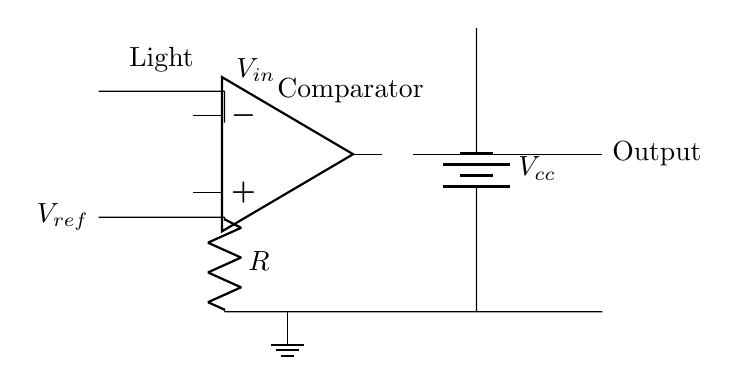What is the input voltage in this circuit? The input voltage, labeled as V_in in the circuit, is taken from the photodiode, which generates a voltage depending on the light levels.
Answer: V_in What component is used to compare the input voltage? The component specifically designed to compare the input voltage against a reference voltage is the operational amplifier, also referred to as a comparator in this setup.
Answer: Operational amplifier What is the purpose of the resistor in the circuit? The resistor in this circuit is likely used for setting a certain gain or limiting the current flowing through the circuit, but in the context of an op-amp comparator, it may also help stabilize the photodiode output.
Answer: Current limiting or gain setting What voltage is used as the reference voltage? The reference voltage, labeled as V_ref, is an external voltage level against which the input voltage is compared. Its exact value is not given in the circuit diagram but is indicated in the schematic.
Answer: V_ref What is the output type of the comparator? The output of the comparator will generally be a digital signal indicating whether the input voltage is above or below the reference voltage, resulting in a high or low output. It is usually considered as either a binary high (1) or low (0) state.
Answer: Digital signal How does the comparator react when V_in exceeds V_ref? When the input voltage (V_in) exceeds the reference voltage (V_ref), the operational amplifier's output will switch to a high state, indicating that the light level is sufficient. This change happens due to the operational principle of the comparator.
Answer: Output goes high 